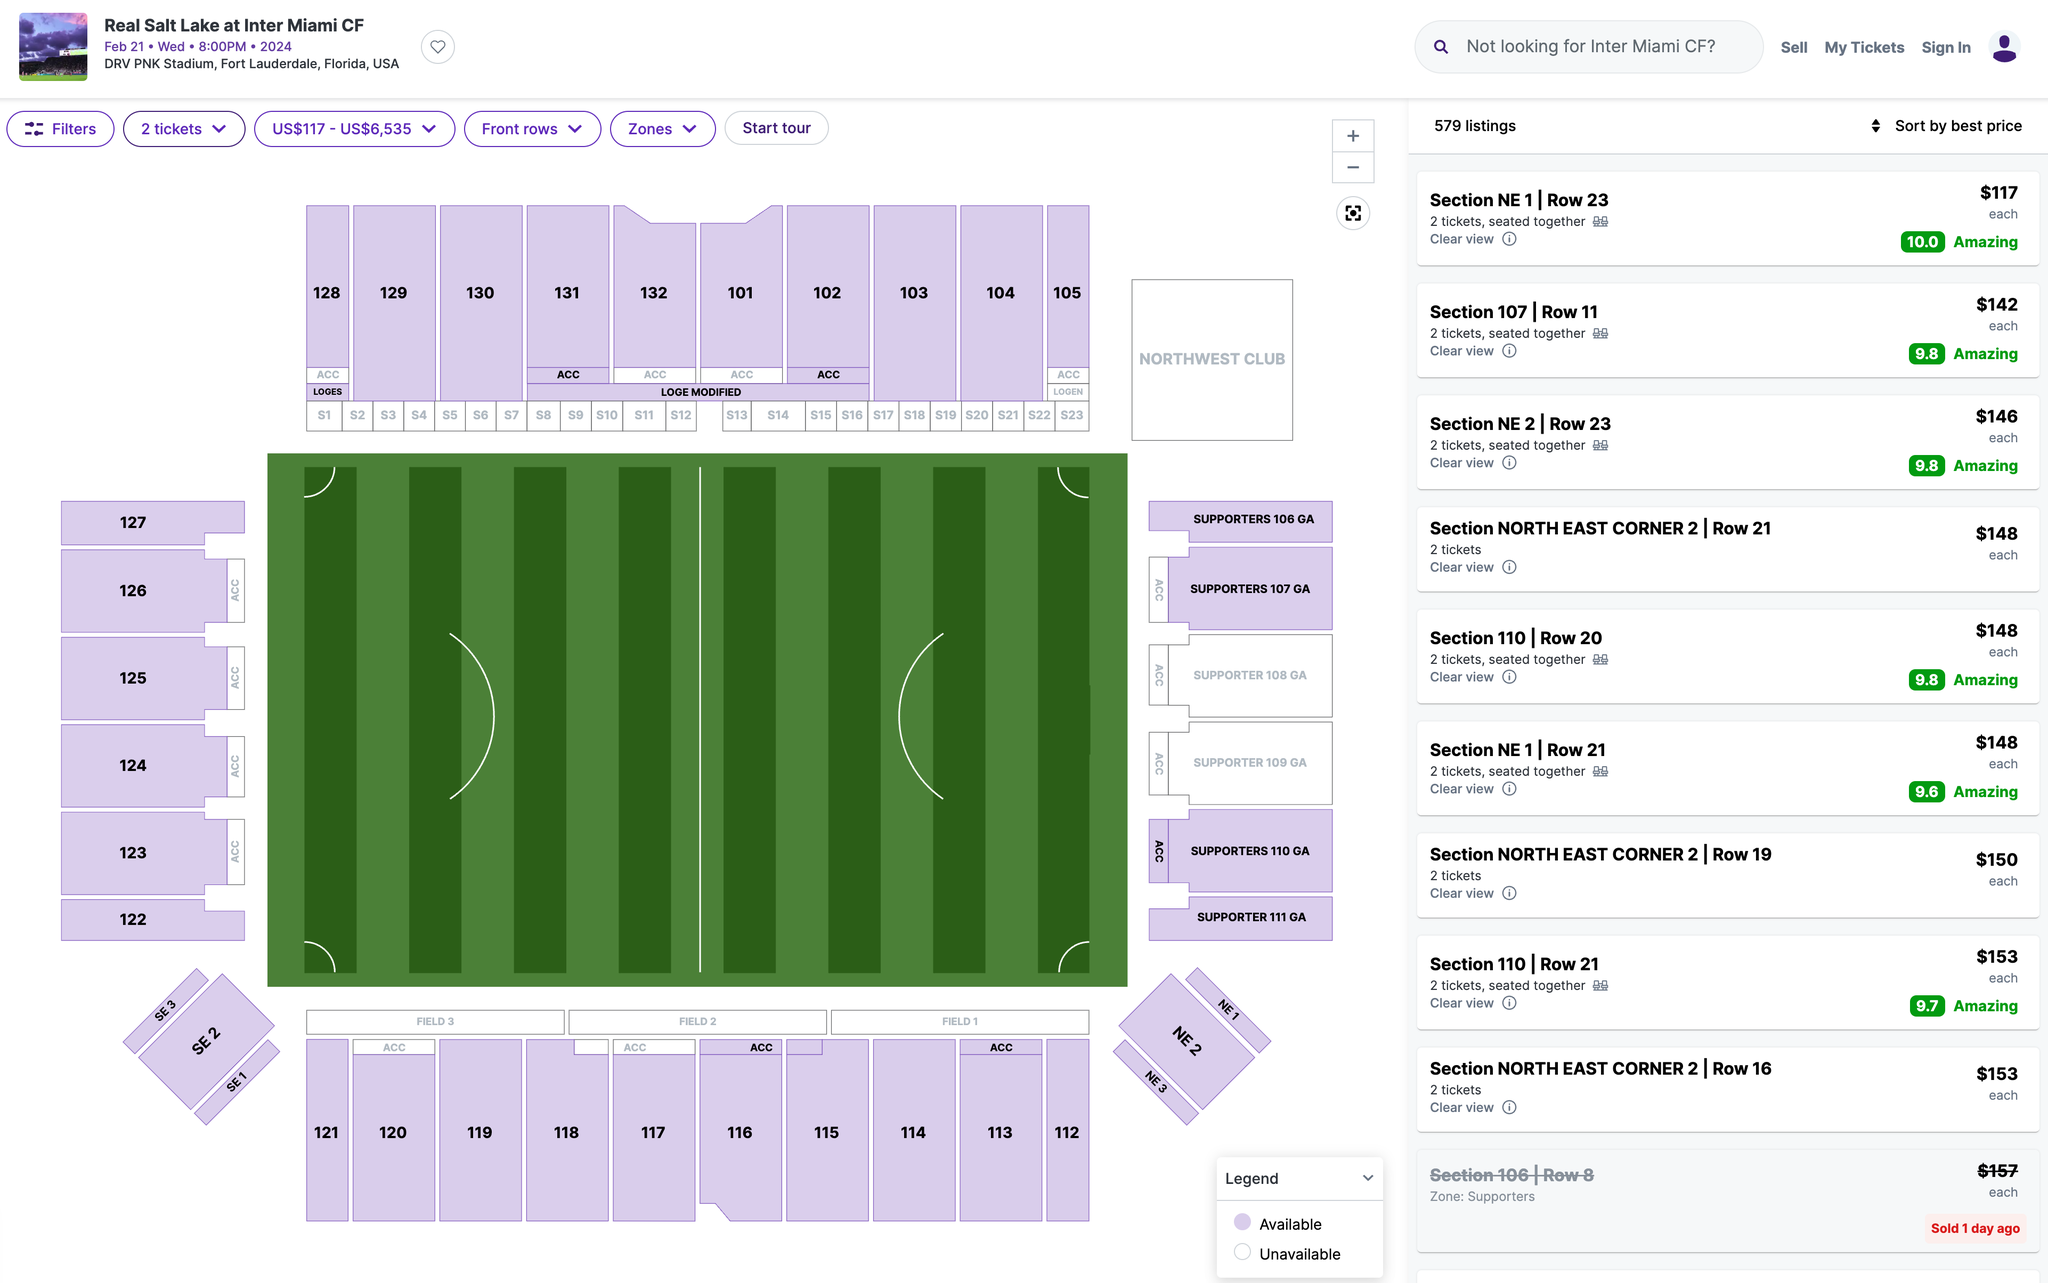Which section's ticket would you recommend I purchase? The best section for you will depend on what you value most in your game experience—whether it's the view, the atmosphere, or the price. Here are a few recommendations based on different criteria:

### Best Value for Money
- **Section NE 1 | Row 23** - Priced at $117 each, this section has an amazing rating of 10.0 and offers a clear view, making it a great value for the price.

### Best View
- **Section 107 | Row 11** - Priced at $142 each, this section has a rating of 9.8. It's closer to the field, offering an excellent view of the action.
- **Section 110 | Row 20** - Priced at $148 each, this section also has a high rating of 9.8 and offers a great view.

### Best Atmosphere
- **Supporters 108 GA** - If you want an energetic and lively atmosphere, the Supporters' sections (108 GA, 109 GA, 110 GA, 111 GA) are great choices. However, availability and pricing information are not provided here.

### Overall Best Rated
- **Section NE 1 | Row 23** - This section not only offers the best value but also has the highest rating (10.0).

### Summary
If you prioritize value and a great view, **Section NE 1 | Row 23** at $117 is highly recommended. If atmosphere and being closer to the action are more important, consider **Section 107 | Row 11** or **Section 110 | Row 20**. 